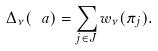<formula> <loc_0><loc_0><loc_500><loc_500>\Delta _ { \nu } ( \ a ) = \sum _ { j \in J } w _ { \nu } ( \pi _ { j } ) .</formula> 